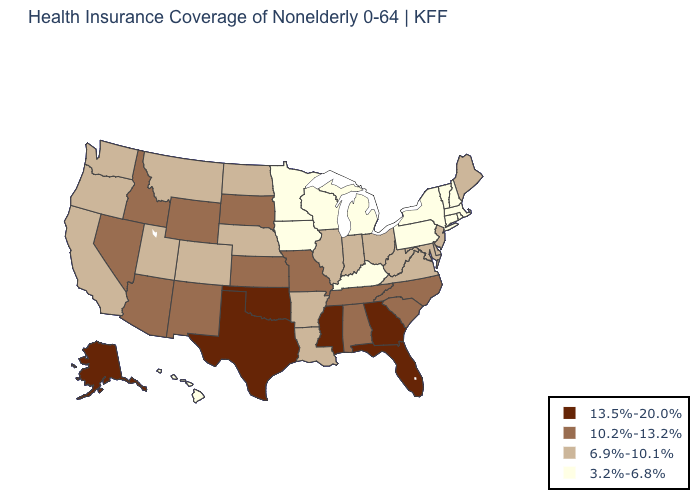Does New Mexico have a higher value than Missouri?
Write a very short answer. No. What is the value of Maryland?
Concise answer only. 6.9%-10.1%. How many symbols are there in the legend?
Give a very brief answer. 4. Name the states that have a value in the range 13.5%-20.0%?
Quick response, please. Alaska, Florida, Georgia, Mississippi, Oklahoma, Texas. How many symbols are there in the legend?
Be succinct. 4. What is the lowest value in states that border West Virginia?
Short answer required. 3.2%-6.8%. Does the first symbol in the legend represent the smallest category?
Quick response, please. No. Name the states that have a value in the range 3.2%-6.8%?
Quick response, please. Connecticut, Hawaii, Iowa, Kentucky, Massachusetts, Michigan, Minnesota, New Hampshire, New York, Pennsylvania, Rhode Island, Vermont, Wisconsin. What is the lowest value in the West?
Give a very brief answer. 3.2%-6.8%. Does West Virginia have a higher value than Louisiana?
Short answer required. No. Does Kentucky have the lowest value in the USA?
Keep it brief. Yes. Among the states that border Connecticut , which have the lowest value?
Give a very brief answer. Massachusetts, New York, Rhode Island. How many symbols are there in the legend?
Keep it brief. 4. What is the value of Alaska?
Concise answer only. 13.5%-20.0%. 